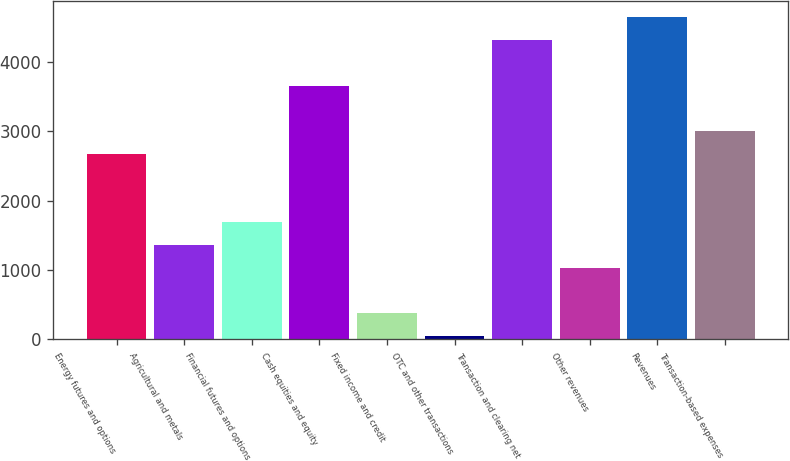Convert chart to OTSL. <chart><loc_0><loc_0><loc_500><loc_500><bar_chart><fcel>Energy futures and options<fcel>Agricultural and metals<fcel>Financial futures and options<fcel>Cash equities and equity<fcel>Fixed income and credit<fcel>OTC and other transactions<fcel>Transaction and clearing net<fcel>Other revenues<fcel>Revenues<fcel>Transaction-based expenses<nl><fcel>2676.4<fcel>1363.2<fcel>1691.5<fcel>3661.3<fcel>378.3<fcel>50<fcel>4317.9<fcel>1034.9<fcel>4646.2<fcel>3004.7<nl></chart> 